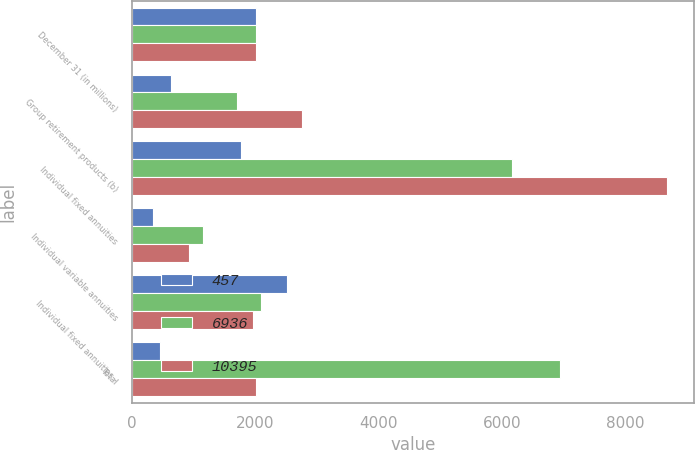Convert chart to OTSL. <chart><loc_0><loc_0><loc_500><loc_500><stacked_bar_chart><ecel><fcel>December 31 (in millions)<fcel>Group retirement products (b)<fcel>Individual fixed annuities<fcel>Individual variable annuities<fcel>Individual fixed annuities -<fcel>Total<nl><fcel>457<fcel>2005<fcel>628<fcel>1759<fcel>336<fcel>2508<fcel>457<nl><fcel>6936<fcel>2004<fcel>1706<fcel>6169<fcel>1145<fcel>2084<fcel>6936<nl><fcel>10395<fcel>2003<fcel>2756<fcel>8679<fcel>927<fcel>1967<fcel>2003<nl></chart> 